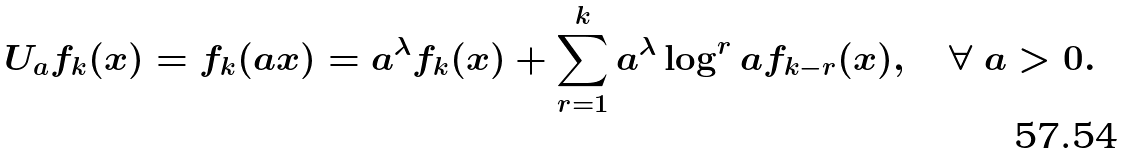Convert formula to latex. <formula><loc_0><loc_0><loc_500><loc_500>U _ { a } f _ { k } ( x ) = f _ { k } ( a x ) = a ^ { \lambda } f _ { k } ( x ) + \sum _ { r = 1 } ^ { k } a ^ { \lambda } \log ^ { r } { a } f _ { k - r } ( x ) , \quad \forall \ a > 0 .</formula> 